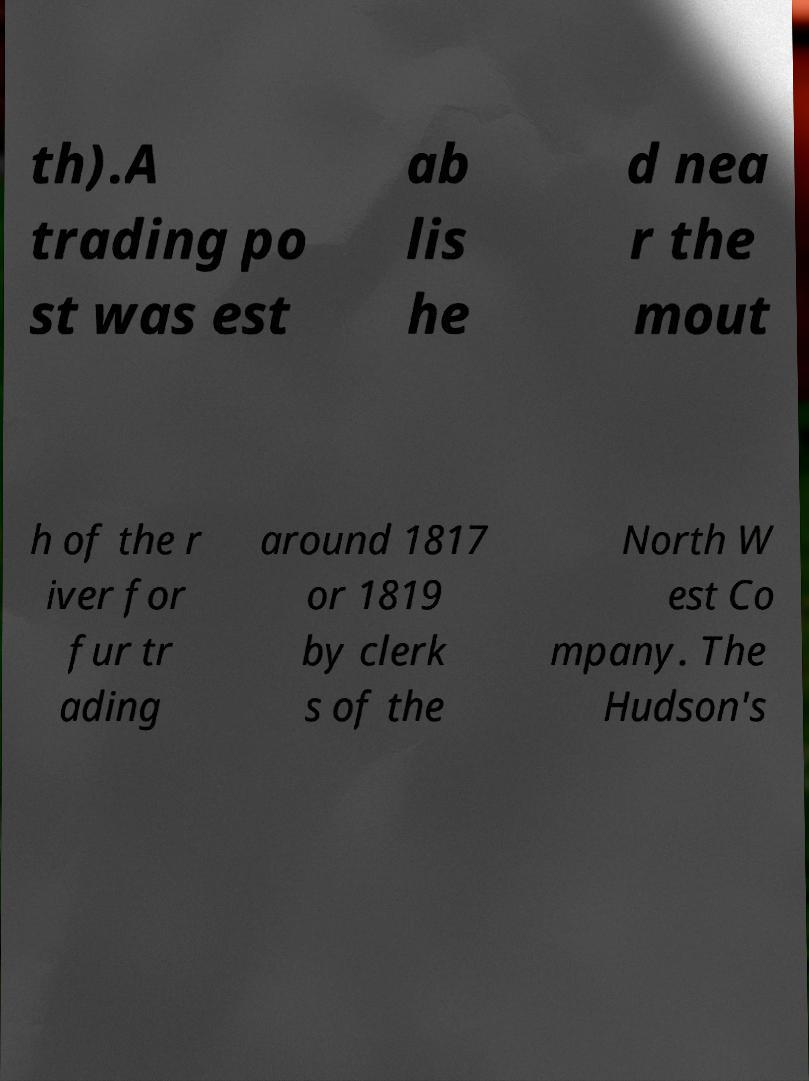Please read and relay the text visible in this image. What does it say? th).A trading po st was est ab lis he d nea r the mout h of the r iver for fur tr ading around 1817 or 1819 by clerk s of the North W est Co mpany. The Hudson's 